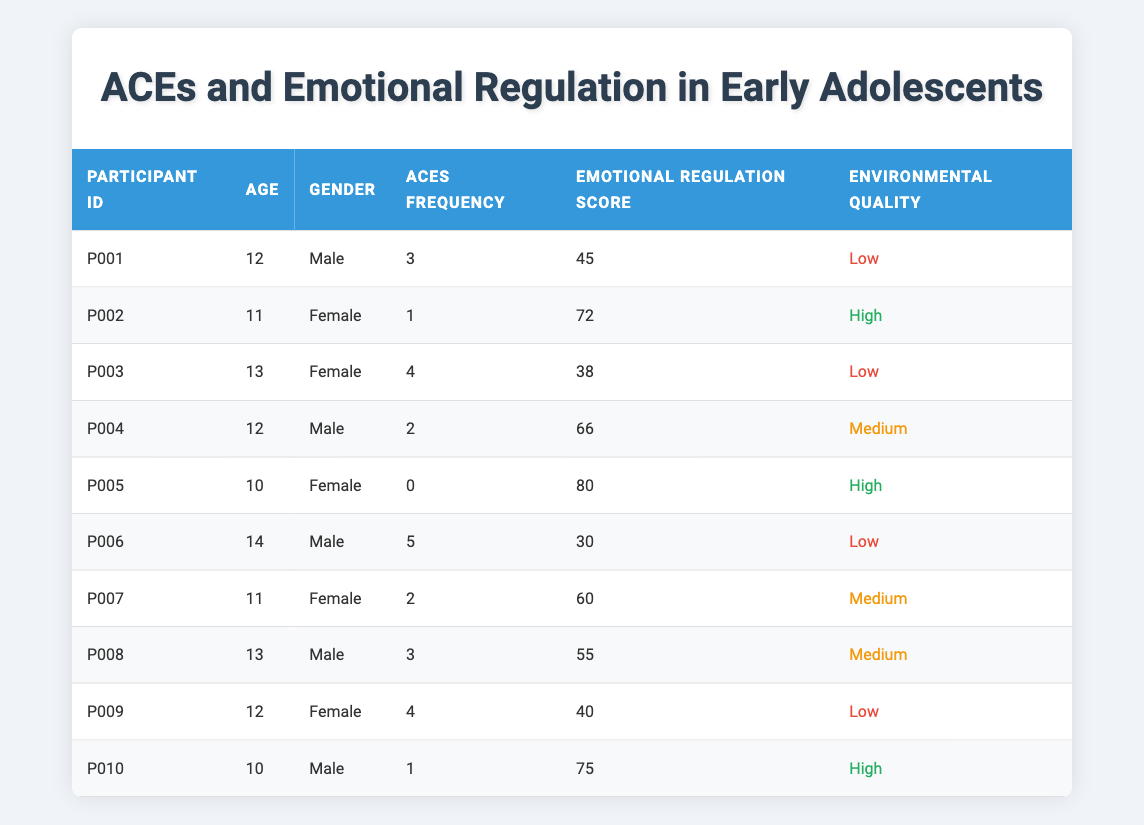What's the ACEs frequency for participant P005? The table shows that participant P005 has an ACEs Frequency of 0, which can be found in the corresponding row under the "ACEs Frequency" column.
Answer: 0 How many participants are in the study? Counting the rows in the table, there are 10 participants listed, corresponding to 10 unique Participant IDs from P001 to P010.
Answer: 10 What is the emotional regulation score for the participant with the highest ACEs frequency? Participant P006 has the highest ACEs Frequency of 5, and their Emotional Regulation Score is 30, as indicated in their row in the table.
Answer: 30 Is there any participant with an emotional regulation score above 75? Looking through the Emotional Regulation Score column, both participants P005 (80) and P010 (75) have scores above 75. Therefore, the answer is yes.
Answer: Yes What is the average emotional regulation score for participants with low environmental quality? The participants with low environmental quality are P001, P003, P006, and P009. Their scores are 45, 38, 30, and 40, respectively. The total is 45 + 38 + 30 + 40 = 153, and there are 4 participants, giving an average score of 153/4 = 38.25.
Answer: 38.25 How many male participants have an emotional regulation score lower than 50? Examining the data for male participants: P001 (45), P006 (30), and P008 (not relevant since score is 55); thus, only P001 and P006 have scores under 50, leading to a total of 2 male participants.
Answer: 2 What is the difference in emotional regulation scores between participants P002 and P010? The emotional regulation score for P002 is 72 and for P010 is 75. The difference is calculated as 75 - 72 = 3.
Answer: 3 Which environmental quality category has the highest average emotional regulation score? The scores for participants based on environmental quality are: Low (P001 45, P003 38, P006 30, P009 40) average = (45 + 38 + 30 + 40) / 4 = 38.25; Medium (P004 66, P007 60, P008 55) average = (66 + 60 + 55) / 3 = 60.33; High (P002 72, P005 80, P010 75) average = (72 + 80 + 75) / 3 = 75.67. The highest average is with High quality.
Answer: High How many total ACEs do female participants have? The female participants and their ACEs frequencies are P002 (1), P003 (4), P005 (0), P007 (2), P009 (4), and P010 (1), totaling 1 + 4 + 0 + 2 + 4 + 1 = 12 ACEs.
Answer: 12 